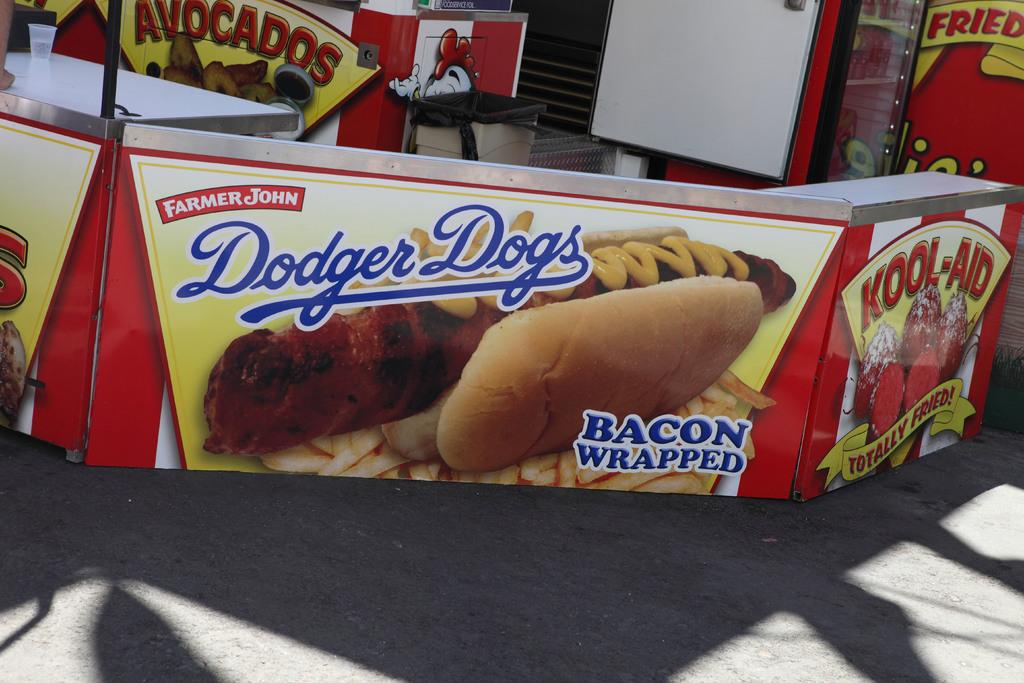What type of path is visible in the image? There is a footpath in the image. What type of furniture is present in the image? There is a table in the image. What type of signage is visible in the image? There is a poster in the image. What type of container is on the table in the image? There is a glass on the table. What type of vertical structure is present in the image? There is a pole in the image. What type of writing surface is visible in the image? There is a whiteboard in the image. What type of shirt is the government wearing in the image? There is no government or shirt present in the image. What type of reading material is visible on the table in the image? There is no reading material visible on the table in the image. 